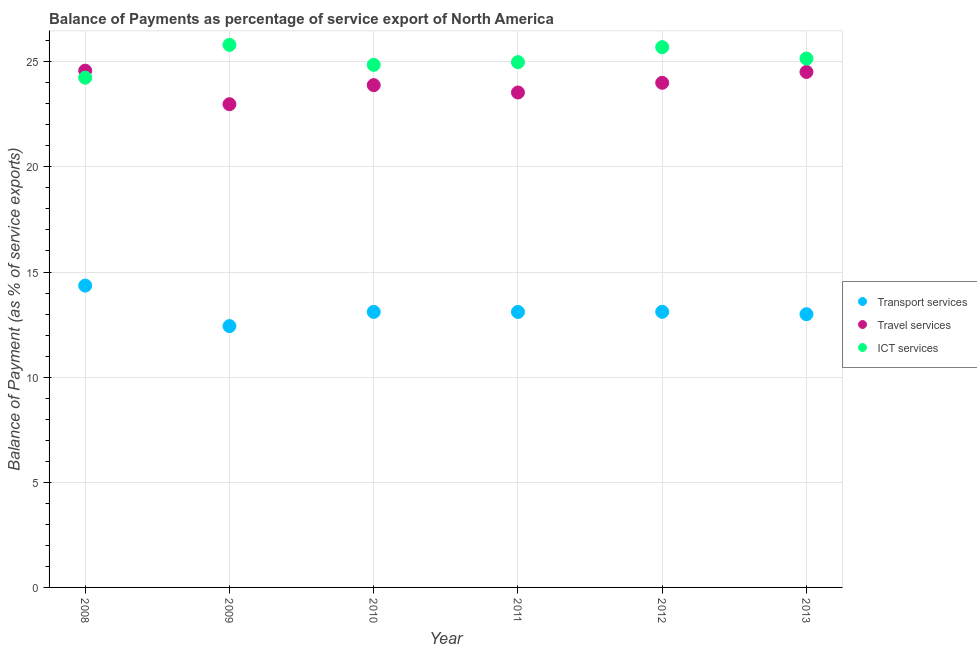How many different coloured dotlines are there?
Your response must be concise. 3. What is the balance of payment of travel services in 2011?
Keep it short and to the point. 23.54. Across all years, what is the maximum balance of payment of ict services?
Provide a short and direct response. 25.8. Across all years, what is the minimum balance of payment of transport services?
Your answer should be compact. 12.43. In which year was the balance of payment of travel services minimum?
Provide a succinct answer. 2009. What is the total balance of payment of travel services in the graph?
Give a very brief answer. 143.5. What is the difference between the balance of payment of ict services in 2009 and that in 2012?
Your response must be concise. 0.11. What is the difference between the balance of payment of ict services in 2010 and the balance of payment of transport services in 2009?
Your answer should be compact. 12.42. What is the average balance of payment of transport services per year?
Your answer should be compact. 13.18. In the year 2008, what is the difference between the balance of payment of transport services and balance of payment of ict services?
Your answer should be very brief. -9.89. What is the ratio of the balance of payment of travel services in 2010 to that in 2011?
Make the answer very short. 1.01. What is the difference between the highest and the second highest balance of payment of ict services?
Keep it short and to the point. 0.11. What is the difference between the highest and the lowest balance of payment of ict services?
Provide a succinct answer. 1.56. In how many years, is the balance of payment of travel services greater than the average balance of payment of travel services taken over all years?
Make the answer very short. 3. Is it the case that in every year, the sum of the balance of payment of transport services and balance of payment of travel services is greater than the balance of payment of ict services?
Give a very brief answer. Yes. Is the balance of payment of travel services strictly greater than the balance of payment of ict services over the years?
Make the answer very short. No. How many years are there in the graph?
Make the answer very short. 6. What is the difference between two consecutive major ticks on the Y-axis?
Provide a succinct answer. 5. Are the values on the major ticks of Y-axis written in scientific E-notation?
Your answer should be compact. No. Does the graph contain any zero values?
Your answer should be very brief. No. How many legend labels are there?
Your answer should be compact. 3. What is the title of the graph?
Your response must be concise. Balance of Payments as percentage of service export of North America. Does "Manufactures" appear as one of the legend labels in the graph?
Make the answer very short. No. What is the label or title of the X-axis?
Offer a terse response. Year. What is the label or title of the Y-axis?
Provide a short and direct response. Balance of Payment (as % of service exports). What is the Balance of Payment (as % of service exports) in Transport services in 2008?
Make the answer very short. 14.35. What is the Balance of Payment (as % of service exports) in Travel services in 2008?
Your answer should be very brief. 24.58. What is the Balance of Payment (as % of service exports) of ICT services in 2008?
Offer a terse response. 24.24. What is the Balance of Payment (as % of service exports) in Transport services in 2009?
Your answer should be compact. 12.43. What is the Balance of Payment (as % of service exports) in Travel services in 2009?
Your answer should be compact. 22.98. What is the Balance of Payment (as % of service exports) in ICT services in 2009?
Provide a short and direct response. 25.8. What is the Balance of Payment (as % of service exports) in Transport services in 2010?
Make the answer very short. 13.1. What is the Balance of Payment (as % of service exports) in Travel services in 2010?
Your response must be concise. 23.89. What is the Balance of Payment (as % of service exports) in ICT services in 2010?
Ensure brevity in your answer.  24.85. What is the Balance of Payment (as % of service exports) of Transport services in 2011?
Provide a succinct answer. 13.1. What is the Balance of Payment (as % of service exports) of Travel services in 2011?
Provide a short and direct response. 23.54. What is the Balance of Payment (as % of service exports) of ICT services in 2011?
Make the answer very short. 24.98. What is the Balance of Payment (as % of service exports) of Transport services in 2012?
Ensure brevity in your answer.  13.11. What is the Balance of Payment (as % of service exports) in Travel services in 2012?
Offer a very short reply. 24. What is the Balance of Payment (as % of service exports) in ICT services in 2012?
Give a very brief answer. 25.69. What is the Balance of Payment (as % of service exports) of Transport services in 2013?
Keep it short and to the point. 12.99. What is the Balance of Payment (as % of service exports) of Travel services in 2013?
Provide a succinct answer. 24.51. What is the Balance of Payment (as % of service exports) of ICT services in 2013?
Your answer should be very brief. 25.15. Across all years, what is the maximum Balance of Payment (as % of service exports) of Transport services?
Ensure brevity in your answer.  14.35. Across all years, what is the maximum Balance of Payment (as % of service exports) of Travel services?
Offer a terse response. 24.58. Across all years, what is the maximum Balance of Payment (as % of service exports) of ICT services?
Provide a succinct answer. 25.8. Across all years, what is the minimum Balance of Payment (as % of service exports) in Transport services?
Offer a terse response. 12.43. Across all years, what is the minimum Balance of Payment (as % of service exports) of Travel services?
Give a very brief answer. 22.98. Across all years, what is the minimum Balance of Payment (as % of service exports) in ICT services?
Keep it short and to the point. 24.24. What is the total Balance of Payment (as % of service exports) in Transport services in the graph?
Your answer should be compact. 79.09. What is the total Balance of Payment (as % of service exports) of Travel services in the graph?
Your answer should be compact. 143.5. What is the total Balance of Payment (as % of service exports) in ICT services in the graph?
Keep it short and to the point. 150.72. What is the difference between the Balance of Payment (as % of service exports) in Transport services in 2008 and that in 2009?
Make the answer very short. 1.93. What is the difference between the Balance of Payment (as % of service exports) of Travel services in 2008 and that in 2009?
Make the answer very short. 1.6. What is the difference between the Balance of Payment (as % of service exports) in ICT services in 2008 and that in 2009?
Offer a very short reply. -1.56. What is the difference between the Balance of Payment (as % of service exports) in Transport services in 2008 and that in 2010?
Make the answer very short. 1.25. What is the difference between the Balance of Payment (as % of service exports) of Travel services in 2008 and that in 2010?
Offer a terse response. 0.69. What is the difference between the Balance of Payment (as % of service exports) in ICT services in 2008 and that in 2010?
Make the answer very short. -0.61. What is the difference between the Balance of Payment (as % of service exports) of Transport services in 2008 and that in 2011?
Make the answer very short. 1.25. What is the difference between the Balance of Payment (as % of service exports) in Travel services in 2008 and that in 2011?
Give a very brief answer. 1.04. What is the difference between the Balance of Payment (as % of service exports) of ICT services in 2008 and that in 2011?
Your response must be concise. -0.74. What is the difference between the Balance of Payment (as % of service exports) in Transport services in 2008 and that in 2012?
Offer a very short reply. 1.25. What is the difference between the Balance of Payment (as % of service exports) of Travel services in 2008 and that in 2012?
Your response must be concise. 0.58. What is the difference between the Balance of Payment (as % of service exports) of ICT services in 2008 and that in 2012?
Keep it short and to the point. -1.45. What is the difference between the Balance of Payment (as % of service exports) in Transport services in 2008 and that in 2013?
Offer a terse response. 1.36. What is the difference between the Balance of Payment (as % of service exports) of Travel services in 2008 and that in 2013?
Give a very brief answer. 0.06. What is the difference between the Balance of Payment (as % of service exports) of ICT services in 2008 and that in 2013?
Your answer should be very brief. -0.91. What is the difference between the Balance of Payment (as % of service exports) in Transport services in 2009 and that in 2010?
Provide a short and direct response. -0.67. What is the difference between the Balance of Payment (as % of service exports) of Travel services in 2009 and that in 2010?
Keep it short and to the point. -0.91. What is the difference between the Balance of Payment (as % of service exports) in ICT services in 2009 and that in 2010?
Give a very brief answer. 0.95. What is the difference between the Balance of Payment (as % of service exports) in Transport services in 2009 and that in 2011?
Offer a terse response. -0.67. What is the difference between the Balance of Payment (as % of service exports) of Travel services in 2009 and that in 2011?
Ensure brevity in your answer.  -0.56. What is the difference between the Balance of Payment (as % of service exports) in ICT services in 2009 and that in 2011?
Your answer should be compact. 0.82. What is the difference between the Balance of Payment (as % of service exports) of Transport services in 2009 and that in 2012?
Give a very brief answer. -0.68. What is the difference between the Balance of Payment (as % of service exports) of Travel services in 2009 and that in 2012?
Provide a short and direct response. -1.02. What is the difference between the Balance of Payment (as % of service exports) in ICT services in 2009 and that in 2012?
Offer a terse response. 0.11. What is the difference between the Balance of Payment (as % of service exports) of Transport services in 2009 and that in 2013?
Offer a terse response. -0.56. What is the difference between the Balance of Payment (as % of service exports) in Travel services in 2009 and that in 2013?
Provide a succinct answer. -1.53. What is the difference between the Balance of Payment (as % of service exports) of ICT services in 2009 and that in 2013?
Your answer should be compact. 0.65. What is the difference between the Balance of Payment (as % of service exports) of Transport services in 2010 and that in 2011?
Offer a very short reply. 0. What is the difference between the Balance of Payment (as % of service exports) in Travel services in 2010 and that in 2011?
Provide a short and direct response. 0.35. What is the difference between the Balance of Payment (as % of service exports) in ICT services in 2010 and that in 2011?
Offer a very short reply. -0.13. What is the difference between the Balance of Payment (as % of service exports) of Transport services in 2010 and that in 2012?
Your answer should be very brief. -0. What is the difference between the Balance of Payment (as % of service exports) of Travel services in 2010 and that in 2012?
Provide a succinct answer. -0.11. What is the difference between the Balance of Payment (as % of service exports) of ICT services in 2010 and that in 2012?
Provide a short and direct response. -0.84. What is the difference between the Balance of Payment (as % of service exports) of Transport services in 2010 and that in 2013?
Provide a short and direct response. 0.11. What is the difference between the Balance of Payment (as % of service exports) of Travel services in 2010 and that in 2013?
Keep it short and to the point. -0.63. What is the difference between the Balance of Payment (as % of service exports) in ICT services in 2010 and that in 2013?
Keep it short and to the point. -0.3. What is the difference between the Balance of Payment (as % of service exports) of Transport services in 2011 and that in 2012?
Provide a short and direct response. -0.01. What is the difference between the Balance of Payment (as % of service exports) in Travel services in 2011 and that in 2012?
Offer a terse response. -0.46. What is the difference between the Balance of Payment (as % of service exports) of ICT services in 2011 and that in 2012?
Your response must be concise. -0.71. What is the difference between the Balance of Payment (as % of service exports) of Transport services in 2011 and that in 2013?
Give a very brief answer. 0.11. What is the difference between the Balance of Payment (as % of service exports) in Travel services in 2011 and that in 2013?
Provide a short and direct response. -0.98. What is the difference between the Balance of Payment (as % of service exports) in ICT services in 2011 and that in 2013?
Give a very brief answer. -0.17. What is the difference between the Balance of Payment (as % of service exports) in Transport services in 2012 and that in 2013?
Ensure brevity in your answer.  0.11. What is the difference between the Balance of Payment (as % of service exports) in Travel services in 2012 and that in 2013?
Your answer should be compact. -0.52. What is the difference between the Balance of Payment (as % of service exports) in ICT services in 2012 and that in 2013?
Your answer should be very brief. 0.54. What is the difference between the Balance of Payment (as % of service exports) in Transport services in 2008 and the Balance of Payment (as % of service exports) in Travel services in 2009?
Provide a short and direct response. -8.63. What is the difference between the Balance of Payment (as % of service exports) of Transport services in 2008 and the Balance of Payment (as % of service exports) of ICT services in 2009?
Ensure brevity in your answer.  -11.45. What is the difference between the Balance of Payment (as % of service exports) of Travel services in 2008 and the Balance of Payment (as % of service exports) of ICT services in 2009?
Keep it short and to the point. -1.23. What is the difference between the Balance of Payment (as % of service exports) of Transport services in 2008 and the Balance of Payment (as % of service exports) of Travel services in 2010?
Provide a short and direct response. -9.53. What is the difference between the Balance of Payment (as % of service exports) of Transport services in 2008 and the Balance of Payment (as % of service exports) of ICT services in 2010?
Offer a very short reply. -10.5. What is the difference between the Balance of Payment (as % of service exports) in Travel services in 2008 and the Balance of Payment (as % of service exports) in ICT services in 2010?
Provide a short and direct response. -0.28. What is the difference between the Balance of Payment (as % of service exports) of Transport services in 2008 and the Balance of Payment (as % of service exports) of Travel services in 2011?
Provide a succinct answer. -9.18. What is the difference between the Balance of Payment (as % of service exports) of Transport services in 2008 and the Balance of Payment (as % of service exports) of ICT services in 2011?
Offer a terse response. -10.63. What is the difference between the Balance of Payment (as % of service exports) of Travel services in 2008 and the Balance of Payment (as % of service exports) of ICT services in 2011?
Ensure brevity in your answer.  -0.4. What is the difference between the Balance of Payment (as % of service exports) of Transport services in 2008 and the Balance of Payment (as % of service exports) of Travel services in 2012?
Your answer should be compact. -9.64. What is the difference between the Balance of Payment (as % of service exports) of Transport services in 2008 and the Balance of Payment (as % of service exports) of ICT services in 2012?
Give a very brief answer. -11.34. What is the difference between the Balance of Payment (as % of service exports) in Travel services in 2008 and the Balance of Payment (as % of service exports) in ICT services in 2012?
Provide a short and direct response. -1.12. What is the difference between the Balance of Payment (as % of service exports) of Transport services in 2008 and the Balance of Payment (as % of service exports) of Travel services in 2013?
Your answer should be very brief. -10.16. What is the difference between the Balance of Payment (as % of service exports) in Transport services in 2008 and the Balance of Payment (as % of service exports) in ICT services in 2013?
Your response must be concise. -10.8. What is the difference between the Balance of Payment (as % of service exports) of Travel services in 2008 and the Balance of Payment (as % of service exports) of ICT services in 2013?
Your answer should be compact. -0.58. What is the difference between the Balance of Payment (as % of service exports) in Transport services in 2009 and the Balance of Payment (as % of service exports) in Travel services in 2010?
Provide a succinct answer. -11.46. What is the difference between the Balance of Payment (as % of service exports) of Transport services in 2009 and the Balance of Payment (as % of service exports) of ICT services in 2010?
Give a very brief answer. -12.42. What is the difference between the Balance of Payment (as % of service exports) in Travel services in 2009 and the Balance of Payment (as % of service exports) in ICT services in 2010?
Provide a short and direct response. -1.87. What is the difference between the Balance of Payment (as % of service exports) in Transport services in 2009 and the Balance of Payment (as % of service exports) in Travel services in 2011?
Your response must be concise. -11.11. What is the difference between the Balance of Payment (as % of service exports) in Transport services in 2009 and the Balance of Payment (as % of service exports) in ICT services in 2011?
Provide a succinct answer. -12.55. What is the difference between the Balance of Payment (as % of service exports) of Travel services in 2009 and the Balance of Payment (as % of service exports) of ICT services in 2011?
Provide a succinct answer. -2. What is the difference between the Balance of Payment (as % of service exports) of Transport services in 2009 and the Balance of Payment (as % of service exports) of Travel services in 2012?
Your answer should be compact. -11.57. What is the difference between the Balance of Payment (as % of service exports) in Transport services in 2009 and the Balance of Payment (as % of service exports) in ICT services in 2012?
Offer a very short reply. -13.26. What is the difference between the Balance of Payment (as % of service exports) in Travel services in 2009 and the Balance of Payment (as % of service exports) in ICT services in 2012?
Offer a terse response. -2.71. What is the difference between the Balance of Payment (as % of service exports) of Transport services in 2009 and the Balance of Payment (as % of service exports) of Travel services in 2013?
Offer a terse response. -12.09. What is the difference between the Balance of Payment (as % of service exports) in Transport services in 2009 and the Balance of Payment (as % of service exports) in ICT services in 2013?
Provide a short and direct response. -12.72. What is the difference between the Balance of Payment (as % of service exports) in Travel services in 2009 and the Balance of Payment (as % of service exports) in ICT services in 2013?
Provide a short and direct response. -2.17. What is the difference between the Balance of Payment (as % of service exports) of Transport services in 2010 and the Balance of Payment (as % of service exports) of Travel services in 2011?
Give a very brief answer. -10.44. What is the difference between the Balance of Payment (as % of service exports) in Transport services in 2010 and the Balance of Payment (as % of service exports) in ICT services in 2011?
Keep it short and to the point. -11.88. What is the difference between the Balance of Payment (as % of service exports) in Travel services in 2010 and the Balance of Payment (as % of service exports) in ICT services in 2011?
Your response must be concise. -1.09. What is the difference between the Balance of Payment (as % of service exports) in Transport services in 2010 and the Balance of Payment (as % of service exports) in Travel services in 2012?
Give a very brief answer. -10.9. What is the difference between the Balance of Payment (as % of service exports) in Transport services in 2010 and the Balance of Payment (as % of service exports) in ICT services in 2012?
Offer a very short reply. -12.59. What is the difference between the Balance of Payment (as % of service exports) of Travel services in 2010 and the Balance of Payment (as % of service exports) of ICT services in 2012?
Provide a succinct answer. -1.8. What is the difference between the Balance of Payment (as % of service exports) in Transport services in 2010 and the Balance of Payment (as % of service exports) in Travel services in 2013?
Your answer should be very brief. -11.41. What is the difference between the Balance of Payment (as % of service exports) in Transport services in 2010 and the Balance of Payment (as % of service exports) in ICT services in 2013?
Provide a succinct answer. -12.05. What is the difference between the Balance of Payment (as % of service exports) in Travel services in 2010 and the Balance of Payment (as % of service exports) in ICT services in 2013?
Give a very brief answer. -1.26. What is the difference between the Balance of Payment (as % of service exports) of Transport services in 2011 and the Balance of Payment (as % of service exports) of Travel services in 2012?
Your response must be concise. -10.9. What is the difference between the Balance of Payment (as % of service exports) of Transport services in 2011 and the Balance of Payment (as % of service exports) of ICT services in 2012?
Make the answer very short. -12.59. What is the difference between the Balance of Payment (as % of service exports) of Travel services in 2011 and the Balance of Payment (as % of service exports) of ICT services in 2012?
Ensure brevity in your answer.  -2.15. What is the difference between the Balance of Payment (as % of service exports) of Transport services in 2011 and the Balance of Payment (as % of service exports) of Travel services in 2013?
Offer a terse response. -11.41. What is the difference between the Balance of Payment (as % of service exports) in Transport services in 2011 and the Balance of Payment (as % of service exports) in ICT services in 2013?
Your answer should be compact. -12.05. What is the difference between the Balance of Payment (as % of service exports) of Travel services in 2011 and the Balance of Payment (as % of service exports) of ICT services in 2013?
Your answer should be very brief. -1.61. What is the difference between the Balance of Payment (as % of service exports) in Transport services in 2012 and the Balance of Payment (as % of service exports) in Travel services in 2013?
Provide a short and direct response. -11.41. What is the difference between the Balance of Payment (as % of service exports) of Transport services in 2012 and the Balance of Payment (as % of service exports) of ICT services in 2013?
Provide a succinct answer. -12.04. What is the difference between the Balance of Payment (as % of service exports) of Travel services in 2012 and the Balance of Payment (as % of service exports) of ICT services in 2013?
Your response must be concise. -1.15. What is the average Balance of Payment (as % of service exports) in Transport services per year?
Give a very brief answer. 13.18. What is the average Balance of Payment (as % of service exports) in Travel services per year?
Your response must be concise. 23.92. What is the average Balance of Payment (as % of service exports) of ICT services per year?
Make the answer very short. 25.12. In the year 2008, what is the difference between the Balance of Payment (as % of service exports) of Transport services and Balance of Payment (as % of service exports) of Travel services?
Ensure brevity in your answer.  -10.22. In the year 2008, what is the difference between the Balance of Payment (as % of service exports) in Transport services and Balance of Payment (as % of service exports) in ICT services?
Your answer should be compact. -9.89. In the year 2008, what is the difference between the Balance of Payment (as % of service exports) in Travel services and Balance of Payment (as % of service exports) in ICT services?
Your answer should be very brief. 0.33. In the year 2009, what is the difference between the Balance of Payment (as % of service exports) of Transport services and Balance of Payment (as % of service exports) of Travel services?
Your response must be concise. -10.55. In the year 2009, what is the difference between the Balance of Payment (as % of service exports) in Transport services and Balance of Payment (as % of service exports) in ICT services?
Your answer should be very brief. -13.37. In the year 2009, what is the difference between the Balance of Payment (as % of service exports) of Travel services and Balance of Payment (as % of service exports) of ICT services?
Offer a very short reply. -2.82. In the year 2010, what is the difference between the Balance of Payment (as % of service exports) of Transport services and Balance of Payment (as % of service exports) of Travel services?
Provide a succinct answer. -10.79. In the year 2010, what is the difference between the Balance of Payment (as % of service exports) in Transport services and Balance of Payment (as % of service exports) in ICT services?
Keep it short and to the point. -11.75. In the year 2010, what is the difference between the Balance of Payment (as % of service exports) of Travel services and Balance of Payment (as % of service exports) of ICT services?
Provide a succinct answer. -0.96. In the year 2011, what is the difference between the Balance of Payment (as % of service exports) of Transport services and Balance of Payment (as % of service exports) of Travel services?
Offer a terse response. -10.44. In the year 2011, what is the difference between the Balance of Payment (as % of service exports) in Transport services and Balance of Payment (as % of service exports) in ICT services?
Your answer should be very brief. -11.88. In the year 2011, what is the difference between the Balance of Payment (as % of service exports) in Travel services and Balance of Payment (as % of service exports) in ICT services?
Your answer should be compact. -1.44. In the year 2012, what is the difference between the Balance of Payment (as % of service exports) of Transport services and Balance of Payment (as % of service exports) of Travel services?
Provide a short and direct response. -10.89. In the year 2012, what is the difference between the Balance of Payment (as % of service exports) in Transport services and Balance of Payment (as % of service exports) in ICT services?
Your response must be concise. -12.59. In the year 2012, what is the difference between the Balance of Payment (as % of service exports) in Travel services and Balance of Payment (as % of service exports) in ICT services?
Your answer should be compact. -1.69. In the year 2013, what is the difference between the Balance of Payment (as % of service exports) in Transport services and Balance of Payment (as % of service exports) in Travel services?
Provide a succinct answer. -11.52. In the year 2013, what is the difference between the Balance of Payment (as % of service exports) in Transport services and Balance of Payment (as % of service exports) in ICT services?
Provide a short and direct response. -12.16. In the year 2013, what is the difference between the Balance of Payment (as % of service exports) in Travel services and Balance of Payment (as % of service exports) in ICT services?
Keep it short and to the point. -0.64. What is the ratio of the Balance of Payment (as % of service exports) of Transport services in 2008 to that in 2009?
Make the answer very short. 1.15. What is the ratio of the Balance of Payment (as % of service exports) of Travel services in 2008 to that in 2009?
Offer a terse response. 1.07. What is the ratio of the Balance of Payment (as % of service exports) in ICT services in 2008 to that in 2009?
Provide a short and direct response. 0.94. What is the ratio of the Balance of Payment (as % of service exports) in Transport services in 2008 to that in 2010?
Give a very brief answer. 1.1. What is the ratio of the Balance of Payment (as % of service exports) of Travel services in 2008 to that in 2010?
Your answer should be compact. 1.03. What is the ratio of the Balance of Payment (as % of service exports) in ICT services in 2008 to that in 2010?
Your answer should be compact. 0.98. What is the ratio of the Balance of Payment (as % of service exports) in Transport services in 2008 to that in 2011?
Provide a short and direct response. 1.1. What is the ratio of the Balance of Payment (as % of service exports) of Travel services in 2008 to that in 2011?
Give a very brief answer. 1.04. What is the ratio of the Balance of Payment (as % of service exports) in ICT services in 2008 to that in 2011?
Your response must be concise. 0.97. What is the ratio of the Balance of Payment (as % of service exports) in Transport services in 2008 to that in 2012?
Your response must be concise. 1.1. What is the ratio of the Balance of Payment (as % of service exports) in Travel services in 2008 to that in 2012?
Offer a terse response. 1.02. What is the ratio of the Balance of Payment (as % of service exports) in ICT services in 2008 to that in 2012?
Make the answer very short. 0.94. What is the ratio of the Balance of Payment (as % of service exports) in Transport services in 2008 to that in 2013?
Your answer should be very brief. 1.1. What is the ratio of the Balance of Payment (as % of service exports) of Travel services in 2008 to that in 2013?
Provide a short and direct response. 1. What is the ratio of the Balance of Payment (as % of service exports) in ICT services in 2008 to that in 2013?
Ensure brevity in your answer.  0.96. What is the ratio of the Balance of Payment (as % of service exports) in Transport services in 2009 to that in 2010?
Give a very brief answer. 0.95. What is the ratio of the Balance of Payment (as % of service exports) in ICT services in 2009 to that in 2010?
Your answer should be very brief. 1.04. What is the ratio of the Balance of Payment (as % of service exports) of Transport services in 2009 to that in 2011?
Offer a very short reply. 0.95. What is the ratio of the Balance of Payment (as % of service exports) of Travel services in 2009 to that in 2011?
Your answer should be very brief. 0.98. What is the ratio of the Balance of Payment (as % of service exports) of ICT services in 2009 to that in 2011?
Your answer should be compact. 1.03. What is the ratio of the Balance of Payment (as % of service exports) of Transport services in 2009 to that in 2012?
Offer a terse response. 0.95. What is the ratio of the Balance of Payment (as % of service exports) in Travel services in 2009 to that in 2012?
Offer a very short reply. 0.96. What is the ratio of the Balance of Payment (as % of service exports) of Transport services in 2009 to that in 2013?
Ensure brevity in your answer.  0.96. What is the ratio of the Balance of Payment (as % of service exports) in Travel services in 2009 to that in 2013?
Give a very brief answer. 0.94. What is the ratio of the Balance of Payment (as % of service exports) in ICT services in 2009 to that in 2013?
Make the answer very short. 1.03. What is the ratio of the Balance of Payment (as % of service exports) in Transport services in 2010 to that in 2011?
Your answer should be very brief. 1. What is the ratio of the Balance of Payment (as % of service exports) of Travel services in 2010 to that in 2011?
Offer a very short reply. 1.01. What is the ratio of the Balance of Payment (as % of service exports) in ICT services in 2010 to that in 2011?
Make the answer very short. 0.99. What is the ratio of the Balance of Payment (as % of service exports) of Transport services in 2010 to that in 2012?
Your response must be concise. 1. What is the ratio of the Balance of Payment (as % of service exports) of Travel services in 2010 to that in 2012?
Make the answer very short. 1. What is the ratio of the Balance of Payment (as % of service exports) of ICT services in 2010 to that in 2012?
Make the answer very short. 0.97. What is the ratio of the Balance of Payment (as % of service exports) in Transport services in 2010 to that in 2013?
Give a very brief answer. 1.01. What is the ratio of the Balance of Payment (as % of service exports) of Travel services in 2010 to that in 2013?
Make the answer very short. 0.97. What is the ratio of the Balance of Payment (as % of service exports) of Travel services in 2011 to that in 2012?
Your answer should be compact. 0.98. What is the ratio of the Balance of Payment (as % of service exports) of ICT services in 2011 to that in 2012?
Ensure brevity in your answer.  0.97. What is the ratio of the Balance of Payment (as % of service exports) of Transport services in 2011 to that in 2013?
Your response must be concise. 1.01. What is the ratio of the Balance of Payment (as % of service exports) of Travel services in 2011 to that in 2013?
Ensure brevity in your answer.  0.96. What is the ratio of the Balance of Payment (as % of service exports) of Transport services in 2012 to that in 2013?
Offer a terse response. 1.01. What is the ratio of the Balance of Payment (as % of service exports) of ICT services in 2012 to that in 2013?
Provide a short and direct response. 1.02. What is the difference between the highest and the second highest Balance of Payment (as % of service exports) of Transport services?
Provide a short and direct response. 1.25. What is the difference between the highest and the second highest Balance of Payment (as % of service exports) of Travel services?
Your answer should be very brief. 0.06. What is the difference between the highest and the second highest Balance of Payment (as % of service exports) of ICT services?
Provide a succinct answer. 0.11. What is the difference between the highest and the lowest Balance of Payment (as % of service exports) of Transport services?
Your answer should be compact. 1.93. What is the difference between the highest and the lowest Balance of Payment (as % of service exports) of Travel services?
Make the answer very short. 1.6. What is the difference between the highest and the lowest Balance of Payment (as % of service exports) of ICT services?
Provide a short and direct response. 1.56. 